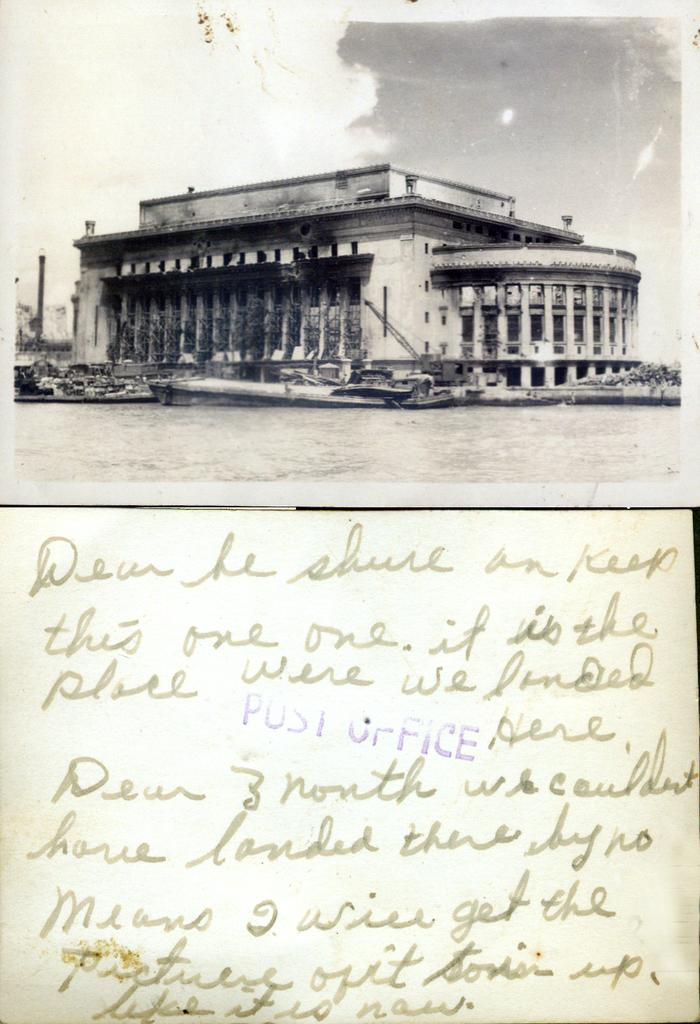Provide a one-sentence caption for the provided image. A postcard with writing and a stating to keep this one showing a picture of an old building,. 